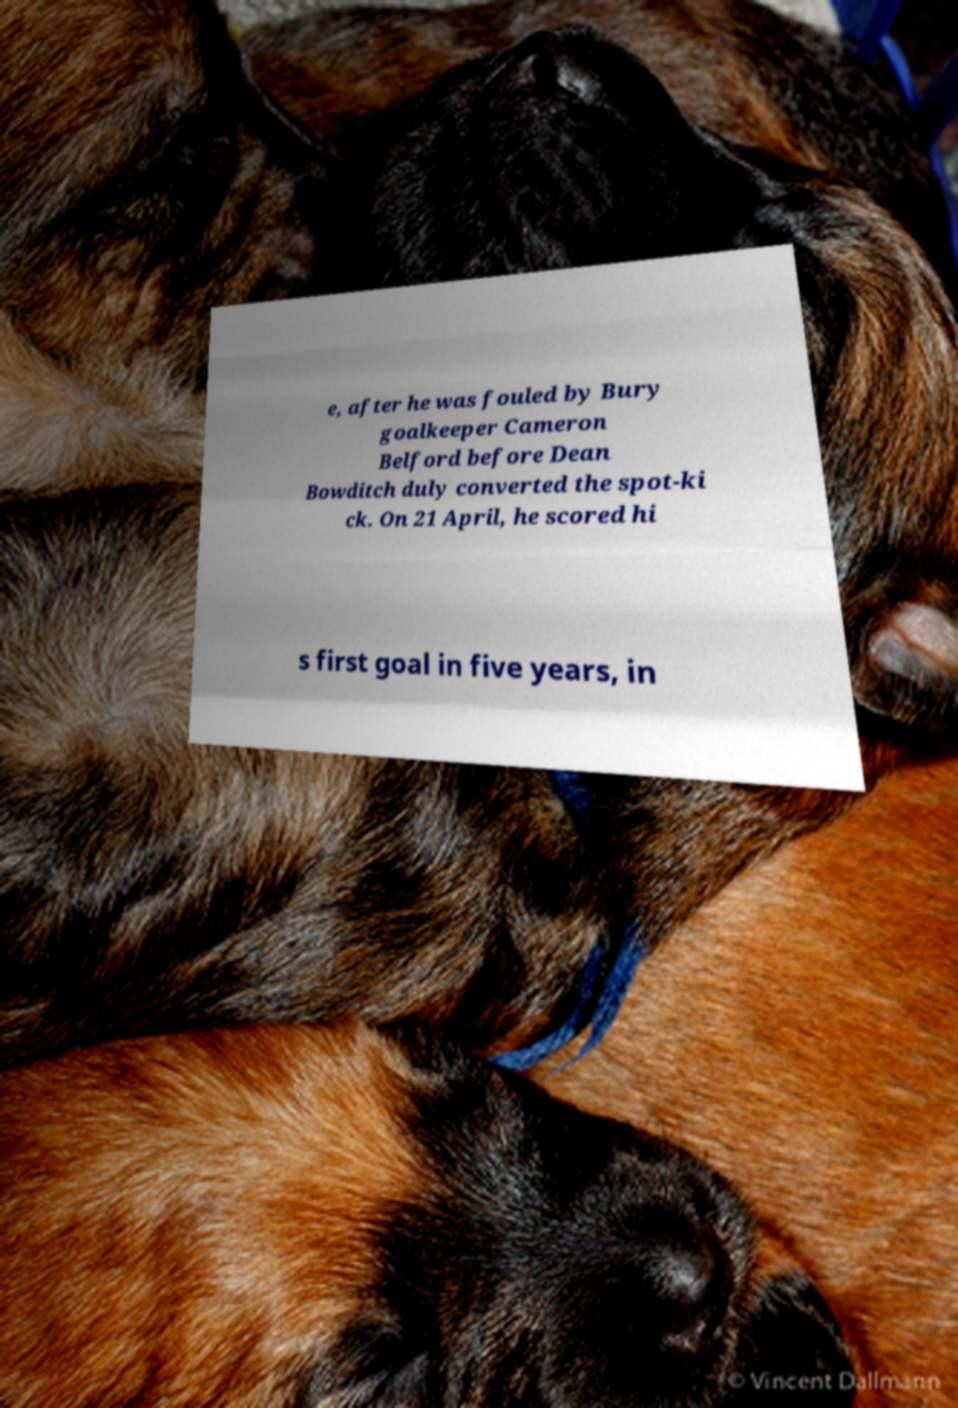Could you extract and type out the text from this image? e, after he was fouled by Bury goalkeeper Cameron Belford before Dean Bowditch duly converted the spot-ki ck. On 21 April, he scored hi s first goal in five years, in 